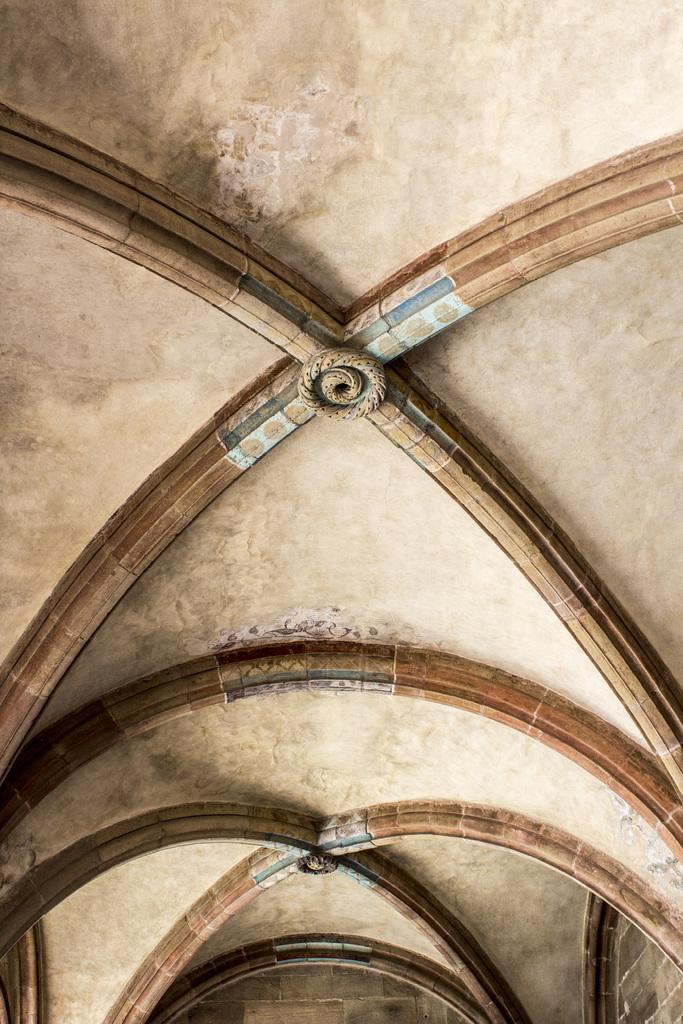Describe this image in one or two sentences. In this picture we can see an inside view of a building, wall, ceiling. 